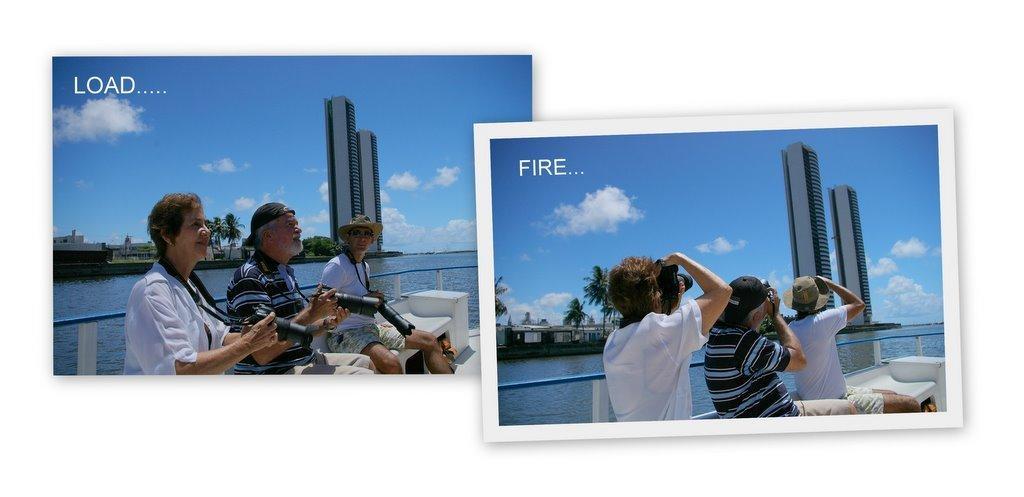Could you give a brief overview of what you see in this image? This is a collage picture and in this picture we can see three people sitting on a bench and holding cameras with their hands, fence, water, buildings, trees and in the background we can see the sky with clouds. 